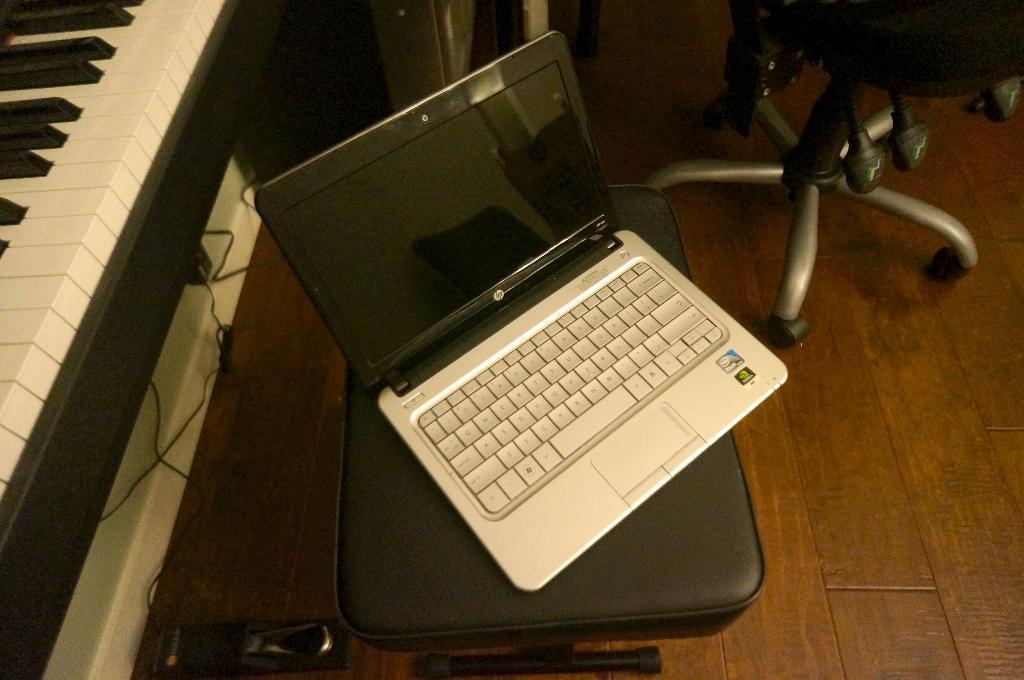In one or two sentences, can you explain what this image depicts? In this picture we can see a laptop which is placed on a chair, on the left side of the picture we can see a Piano keyboard, on the right top corner of the image we can see a chair. 